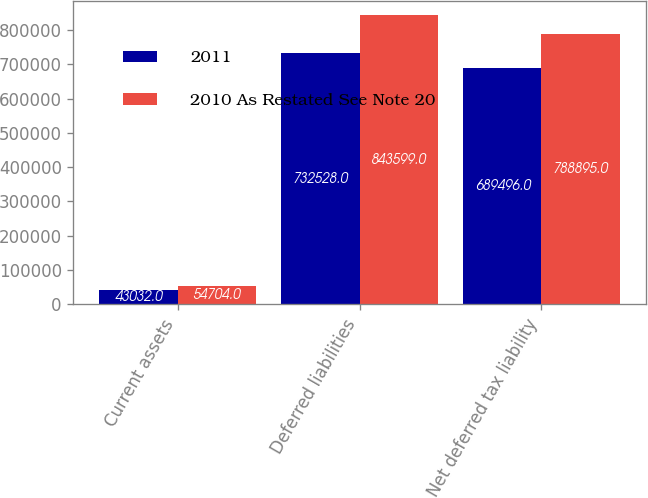Convert chart to OTSL. <chart><loc_0><loc_0><loc_500><loc_500><stacked_bar_chart><ecel><fcel>Current assets<fcel>Deferred liabilities<fcel>Net deferred tax liability<nl><fcel>2011<fcel>43032<fcel>732528<fcel>689496<nl><fcel>2010 As Restated See Note 20<fcel>54704<fcel>843599<fcel>788895<nl></chart> 